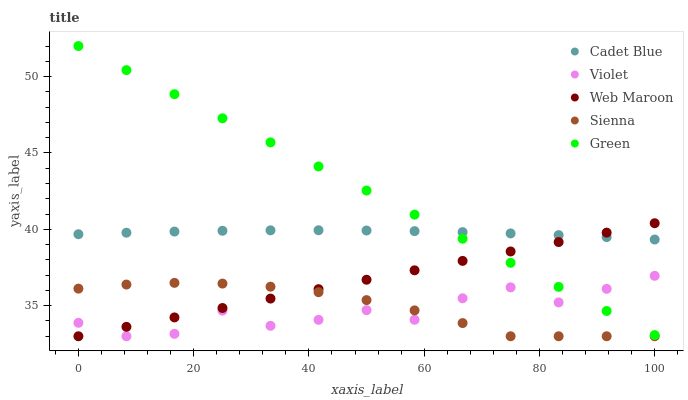Does Violet have the minimum area under the curve?
Answer yes or no. Yes. Does Green have the maximum area under the curve?
Answer yes or no. Yes. Does Cadet Blue have the minimum area under the curve?
Answer yes or no. No. Does Cadet Blue have the maximum area under the curve?
Answer yes or no. No. Is Web Maroon the smoothest?
Answer yes or no. Yes. Is Violet the roughest?
Answer yes or no. Yes. Is Green the smoothest?
Answer yes or no. No. Is Green the roughest?
Answer yes or no. No. Does Sienna have the lowest value?
Answer yes or no. Yes. Does Green have the lowest value?
Answer yes or no. No. Does Green have the highest value?
Answer yes or no. Yes. Does Cadet Blue have the highest value?
Answer yes or no. No. Is Sienna less than Green?
Answer yes or no. Yes. Is Green greater than Sienna?
Answer yes or no. Yes. Does Web Maroon intersect Sienna?
Answer yes or no. Yes. Is Web Maroon less than Sienna?
Answer yes or no. No. Is Web Maroon greater than Sienna?
Answer yes or no. No. Does Sienna intersect Green?
Answer yes or no. No. 